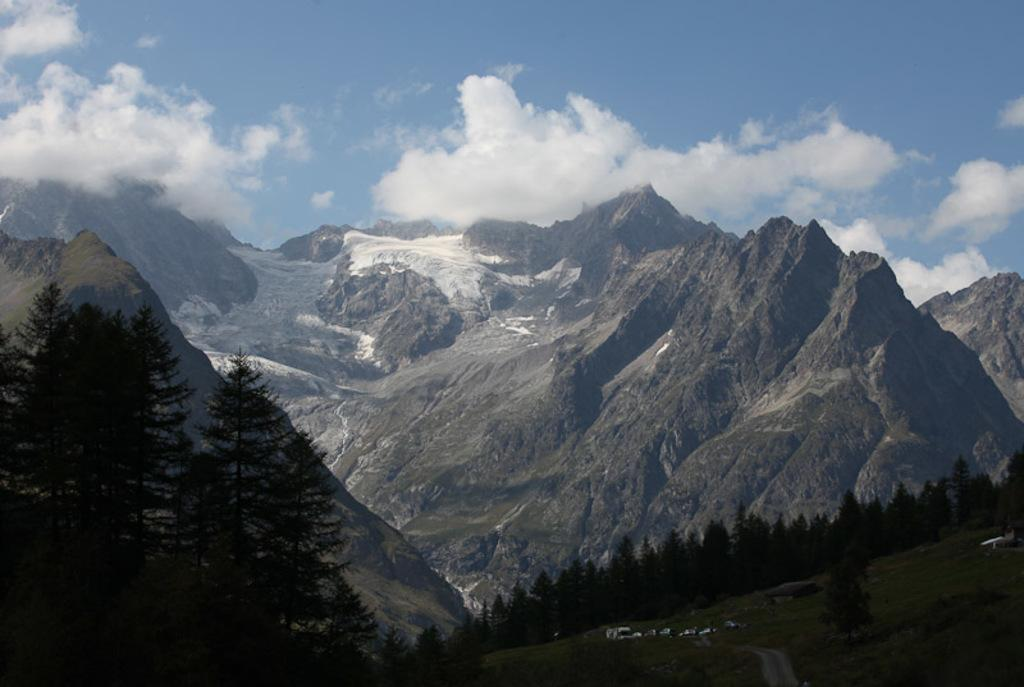What type of vegetation can be seen in the image? There are trees in the image. What color are the trees? The trees are green. What can be seen in the distance behind the trees? There are mountains in the background of the image. What colors are visible in the sky? The sky is blue and white. Did the trees cause a surprise earthquake on the sidewalk in the image? There is no mention of an earthquake or sidewalk in the image, and trees do not cause earthquakes. 